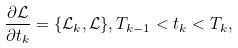<formula> <loc_0><loc_0><loc_500><loc_500>\frac { \partial \mathcal { L } } { \partial t _ { k } } = \{ \mathcal { L } _ { k } , \mathcal { L } \} , T _ { k - 1 } < t _ { k } < T _ { k } ,</formula> 